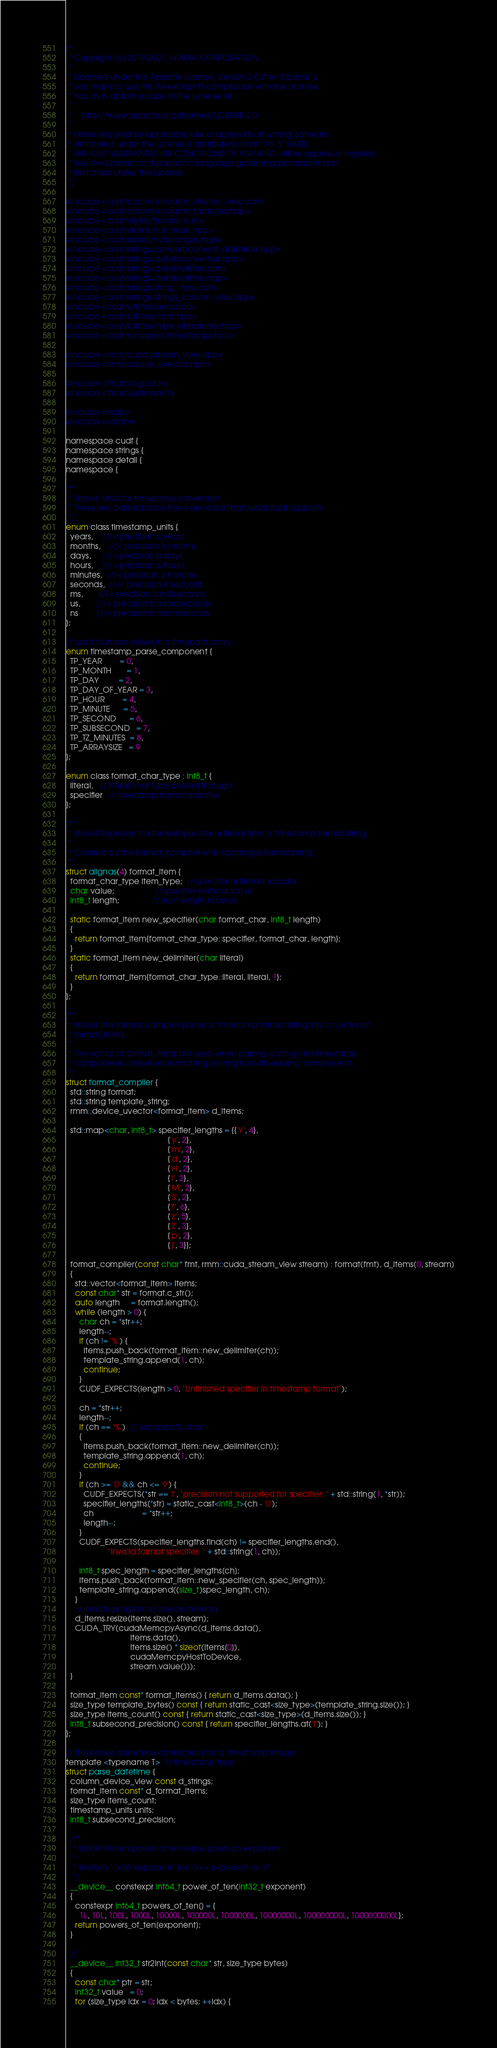Convert code to text. <code><loc_0><loc_0><loc_500><loc_500><_Cuda_>/*
 * Copyright (c) 2019-2021, NVIDIA CORPORATION.
 *
 * Licensed under the Apache License, Version 2.0 (the "License");
 * you may not use this file except in compliance with the License.
 * You may obtain a copy of the License at
 *
 *     http://www.apache.org/licenses/LICENSE-2.0
 *
 * Unless required by applicable law or agreed to in writing, software
 * distributed under the License is distributed on an "AS IS" BASIS,
 * WITHOUT WARRANTIES OR CONDITIONS OF ANY KIND, either express or implied.
 * See the License for the specific language governing permissions and
 * limitations under the License.
 */

#include <cudf/column/column_device_view.cuh>
#include <cudf/column/column_factories.hpp>
#include <cudf/detail/iterator.cuh>
#include <cudf/detail/null_mask.hpp>
#include <cudf/detail/nvtx/ranges.hpp>
#include <cudf/strings/convert/convert_datetime.hpp>
#include <cudf/strings/detail/converters.hpp>
#include <cudf/strings/detail/utilities.cuh>
#include <cudf/strings/detail/utilities.hpp>
#include <cudf/strings/string_view.cuh>
#include <cudf/strings/strings_column_view.hpp>
#include <cudf/utilities/error.hpp>
#include <cudf/utilities/traits.hpp>
#include <cudf/utilities/type_dispatcher.hpp>
#include <cudf/wrappers/timestamps.hpp>

#include <rmm/cuda_stream_view.hpp>
#include <rmm/device_uvector.hpp>

#include <thrust/logical.h>
#include <thrust/optional.h>

#include <map>
#include <vector>

namespace cudf {
namespace strings {
namespace detail {
namespace {

/**
 * @brief  Units for timestamp conversion.
 * These are defined since there are more than what cudf supports.
 */
enum class timestamp_units {
  years,    ///< precision is years
  months,   ///< precision is months
  days,     ///< precision is days
  hours,    ///< precision is hours
  minutes,  ///< precision is minutes
  seconds,  ///< precision is seconds
  ms,       ///< precision is milliseconds
  us,       ///< precision is microseconds
  ns        ///< precision is nanoseconds
};

// used to index values in a timeparts array
enum timestamp_parse_component {
  TP_YEAR        = 0,
  TP_MONTH       = 1,
  TP_DAY         = 2,
  TP_DAY_OF_YEAR = 3,
  TP_HOUR        = 4,
  TP_MINUTE      = 5,
  TP_SECOND      = 6,
  TP_SUBSECOND   = 7,
  TP_TZ_MINUTES  = 8,
  TP_ARRAYSIZE   = 9
};

enum class format_char_type : int8_t {
  literal,   // literal char type passed through
  specifier  // timestamp format specifier
};

/**
 * @brief Represents a format specifier or literal from a timestamp format string.
 *
 * Created by the format_compiler when parsing a format string.
 */
struct alignas(4) format_item {
  format_char_type item_type;  // specifier or literal indicator
  char value;                  // specifier or literal value
  int8_t length;               // item length in bytes

  static format_item new_specifier(char format_char, int8_t length)
  {
    return format_item{format_char_type::specifier, format_char, length};
  }
  static format_item new_delimiter(char literal)
  {
    return format_item{format_char_type::literal, literal, 1};
  }
};

/**
 * @brief The format_compiler parses a timestamp format string into a vector of
 * format_items.
 *
 * The vector of format_items are used when parsing a string into timestamp
 * components and when formatting a string from timestamp components.
 */
struct format_compiler {
  std::string format;
  std::string template_string;
  rmm::device_uvector<format_item> d_items;

  std::map<char, int8_t> specifier_lengths = {{'Y', 4},
                                              {'y', 2},
                                              {'m', 2},
                                              {'d', 2},
                                              {'H', 2},
                                              {'I', 2},
                                              {'M', 2},
                                              {'S', 2},
                                              {'f', 6},
                                              {'z', 5},
                                              {'Z', 3},
                                              {'p', 2},
                                              {'j', 3}};

  format_compiler(const char* fmt, rmm::cuda_stream_view stream) : format(fmt), d_items(0, stream)
  {
    std::vector<format_item> items;
    const char* str = format.c_str();
    auto length     = format.length();
    while (length > 0) {
      char ch = *str++;
      length--;
      if (ch != '%') {
        items.push_back(format_item::new_delimiter(ch));
        template_string.append(1, ch);
        continue;
      }
      CUDF_EXPECTS(length > 0, "Unfinished specifier in timestamp format");

      ch = *str++;
      length--;
      if (ch == '%')  // escaped % char
      {
        items.push_back(format_item::new_delimiter(ch));
        template_string.append(1, ch);
        continue;
      }
      if (ch >= '0' && ch <= '9') {
        CUDF_EXPECTS(*str == 'f', "precision not supported for specifier: " + std::string(1, *str));
        specifier_lengths[*str] = static_cast<int8_t>(ch - '0');
        ch                      = *str++;
        length--;
      }
      CUDF_EXPECTS(specifier_lengths.find(ch) != specifier_lengths.end(),
                   "invalid format specifier: " + std::string(1, ch));

      int8_t spec_length = specifier_lengths[ch];
      items.push_back(format_item::new_specifier(ch, spec_length));
      template_string.append((size_t)spec_length, ch);
    }
    // create program in device memory
    d_items.resize(items.size(), stream);
    CUDA_TRY(cudaMemcpyAsync(d_items.data(),
                             items.data(),
                             items.size() * sizeof(items[0]),
                             cudaMemcpyHostToDevice,
                             stream.value()));
  }

  format_item const* format_items() { return d_items.data(); }
  size_type template_bytes() const { return static_cast<size_type>(template_string.size()); }
  size_type items_count() const { return static_cast<size_type>(d_items.size()); }
  int8_t subsecond_precision() const { return specifier_lengths.at('f'); }
};

// this parses date/time characters into a timestamp integer
template <typename T>  // timestamp type
struct parse_datetime {
  column_device_view const d_strings;
  format_item const* d_format_items;
  size_type items_count;
  timestamp_units units;
  int8_t subsecond_precision;

  /**
   * @brief Return power of ten value given an exponent.
   *
   * @return `1x10^exponent` for `0 <= exponent <= 9`
   */
  __device__ constexpr int64_t power_of_ten(int32_t exponent)
  {
    constexpr int64_t powers_of_ten[] = {
      1L, 10L, 100L, 1000L, 10000L, 100000L, 1000000L, 10000000L, 100000000L, 1000000000L};
    return powers_of_ten[exponent];
  }

  //
  __device__ int32_t str2int(const char* str, size_type bytes)
  {
    const char* ptr = str;
    int32_t value   = 0;
    for (size_type idx = 0; idx < bytes; ++idx) {</code> 